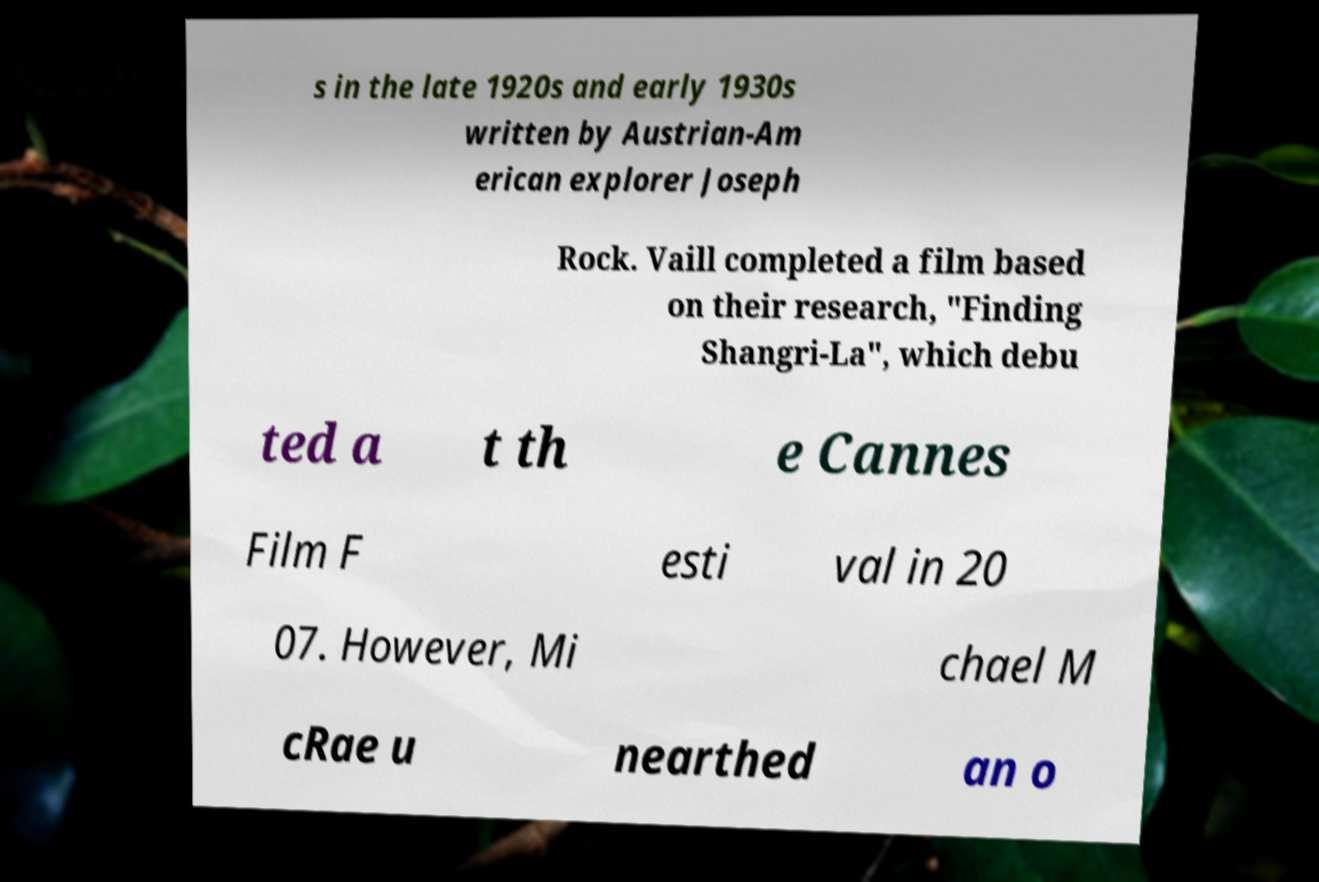Can you read and provide the text displayed in the image?This photo seems to have some interesting text. Can you extract and type it out for me? s in the late 1920s and early 1930s written by Austrian-Am erican explorer Joseph Rock. Vaill completed a film based on their research, "Finding Shangri-La", which debu ted a t th e Cannes Film F esti val in 20 07. However, Mi chael M cRae u nearthed an o 